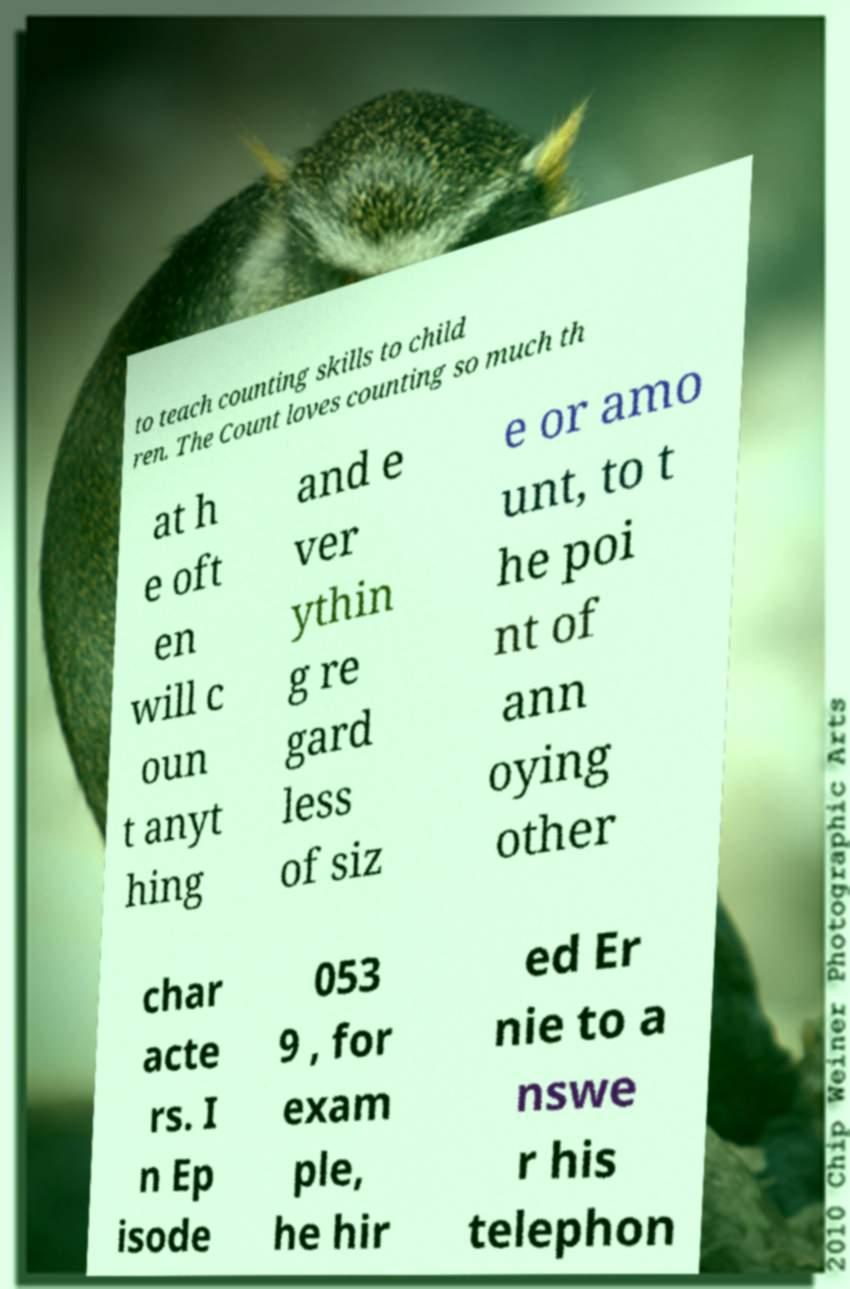I need the written content from this picture converted into text. Can you do that? to teach counting skills to child ren. The Count loves counting so much th at h e oft en will c oun t anyt hing and e ver ythin g re gard less of siz e or amo unt, to t he poi nt of ann oying other char acte rs. I n Ep isode 053 9 , for exam ple, he hir ed Er nie to a nswe r his telephon 